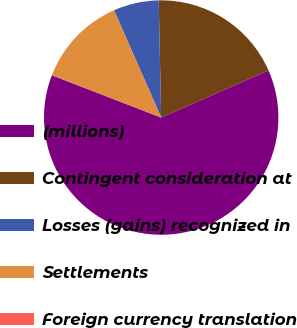<chart> <loc_0><loc_0><loc_500><loc_500><pie_chart><fcel>(millions)<fcel>Contingent consideration at<fcel>Losses (gains) recognized in<fcel>Settlements<fcel>Foreign currency translation<nl><fcel>62.46%<fcel>18.75%<fcel>6.26%<fcel>12.51%<fcel>0.02%<nl></chart> 